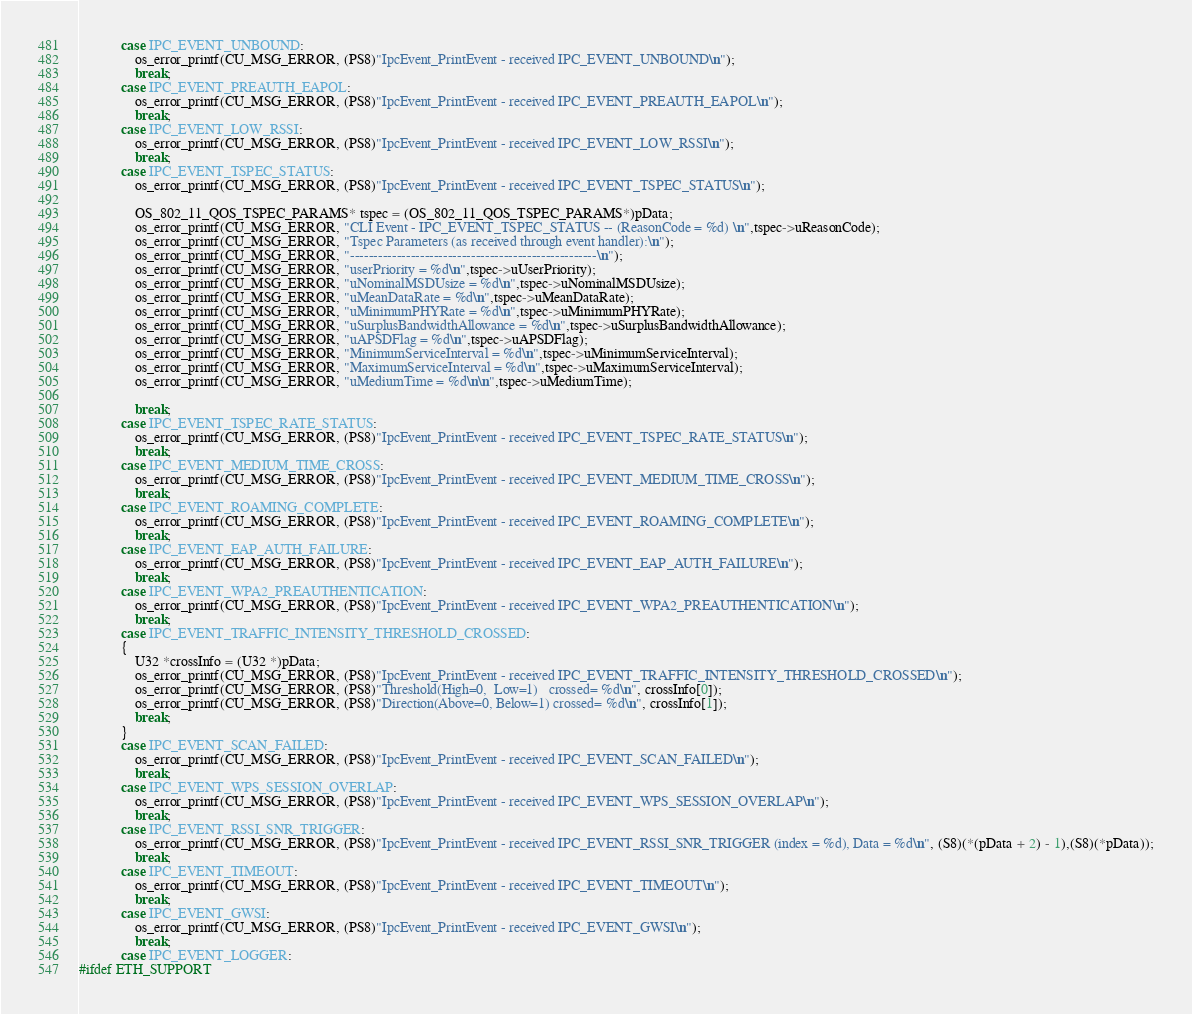Convert code to text. <code><loc_0><loc_0><loc_500><loc_500><_C_>            case IPC_EVENT_UNBOUND:
                os_error_printf(CU_MSG_ERROR, (PS8)"IpcEvent_PrintEvent - received IPC_EVENT_UNBOUND\n");
                break;
            case IPC_EVENT_PREAUTH_EAPOL:
                os_error_printf(CU_MSG_ERROR, (PS8)"IpcEvent_PrintEvent - received IPC_EVENT_PREAUTH_EAPOL\n");
                break;
            case IPC_EVENT_LOW_RSSI:
                os_error_printf(CU_MSG_ERROR, (PS8)"IpcEvent_PrintEvent - received IPC_EVENT_LOW_RSSI\n");
                break;
            case IPC_EVENT_TSPEC_STATUS:
                os_error_printf(CU_MSG_ERROR, (PS8)"IpcEvent_PrintEvent - received IPC_EVENT_TSPEC_STATUS\n");

                OS_802_11_QOS_TSPEC_PARAMS* tspec = (OS_802_11_QOS_TSPEC_PARAMS*)pData;
                os_error_printf(CU_MSG_ERROR, "CLI Event - IPC_EVENT_TSPEC_STATUS -- (ReasonCode = %d) \n",tspec->uReasonCode);
                os_error_printf(CU_MSG_ERROR, "Tspec Parameters (as received through event handler):\n");
                os_error_printf(CU_MSG_ERROR, "-----------------------------------------------------\n");
                os_error_printf(CU_MSG_ERROR, "userPriority = %d\n",tspec->uUserPriority);
                os_error_printf(CU_MSG_ERROR, "uNominalMSDUsize = %d\n",tspec->uNominalMSDUsize);
                os_error_printf(CU_MSG_ERROR, "uMeanDataRate = %d\n",tspec->uMeanDataRate);
                os_error_printf(CU_MSG_ERROR, "uMinimumPHYRate = %d\n",tspec->uMinimumPHYRate);
                os_error_printf(CU_MSG_ERROR, "uSurplusBandwidthAllowance = %d\n",tspec->uSurplusBandwidthAllowance);
                os_error_printf(CU_MSG_ERROR, "uAPSDFlag = %d\n",tspec->uAPSDFlag);
                os_error_printf(CU_MSG_ERROR, "MinimumServiceInterval = %d\n",tspec->uMinimumServiceInterval);
                os_error_printf(CU_MSG_ERROR, "MaximumServiceInterval = %d\n",tspec->uMaximumServiceInterval);
                os_error_printf(CU_MSG_ERROR, "uMediumTime = %d\n\n",tspec->uMediumTime);
           
                break;
            case IPC_EVENT_TSPEC_RATE_STATUS:
                os_error_printf(CU_MSG_ERROR, (PS8)"IpcEvent_PrintEvent - received IPC_EVENT_TSPEC_RATE_STATUS\n");
                break;
            case IPC_EVENT_MEDIUM_TIME_CROSS:
                os_error_printf(CU_MSG_ERROR, (PS8)"IpcEvent_PrintEvent - received IPC_EVENT_MEDIUM_TIME_CROSS\n");
                break;
            case IPC_EVENT_ROAMING_COMPLETE:
                os_error_printf(CU_MSG_ERROR, (PS8)"IpcEvent_PrintEvent - received IPC_EVENT_ROAMING_COMPLETE\n");
                break;
            case IPC_EVENT_EAP_AUTH_FAILURE:
                os_error_printf(CU_MSG_ERROR, (PS8)"IpcEvent_PrintEvent - received IPC_EVENT_EAP_AUTH_FAILURE\n");
                break;
            case IPC_EVENT_WPA2_PREAUTHENTICATION:
                os_error_printf(CU_MSG_ERROR, (PS8)"IpcEvent_PrintEvent - received IPC_EVENT_WPA2_PREAUTHENTICATION\n");
                break;
            case IPC_EVENT_TRAFFIC_INTENSITY_THRESHOLD_CROSSED:
            {
                U32 *crossInfo = (U32 *)pData;
                os_error_printf(CU_MSG_ERROR, (PS8)"IpcEvent_PrintEvent - received IPC_EVENT_TRAFFIC_INTENSITY_THRESHOLD_CROSSED\n");
                os_error_printf(CU_MSG_ERROR, (PS8)"Threshold(High=0,  Low=1)   crossed= %d\n", crossInfo[0]);
                os_error_printf(CU_MSG_ERROR, (PS8)"Direction(Above=0, Below=1) crossed= %d\n", crossInfo[1]);
                break;
            }
            case IPC_EVENT_SCAN_FAILED:
                os_error_printf(CU_MSG_ERROR, (PS8)"IpcEvent_PrintEvent - received IPC_EVENT_SCAN_FAILED\n");
                break;
            case IPC_EVENT_WPS_SESSION_OVERLAP:
                os_error_printf(CU_MSG_ERROR, (PS8)"IpcEvent_PrintEvent - received IPC_EVENT_WPS_SESSION_OVERLAP\n");
                break;
            case IPC_EVENT_RSSI_SNR_TRIGGER:
                os_error_printf(CU_MSG_ERROR, (PS8)"IpcEvent_PrintEvent - received IPC_EVENT_RSSI_SNR_TRIGGER (index = %d), Data = %d\n", (S8)(*(pData + 2) - 1),(S8)(*pData));
                break;
            case IPC_EVENT_TIMEOUT:
                os_error_printf(CU_MSG_ERROR, (PS8)"IpcEvent_PrintEvent - received IPC_EVENT_TIMEOUT\n");
                break;
            case IPC_EVENT_GWSI:
                os_error_printf(CU_MSG_ERROR, (PS8)"IpcEvent_PrintEvent - received IPC_EVENT_GWSI\n");
                break;
            case IPC_EVENT_LOGGER:
#ifdef ETH_SUPPORT</code> 